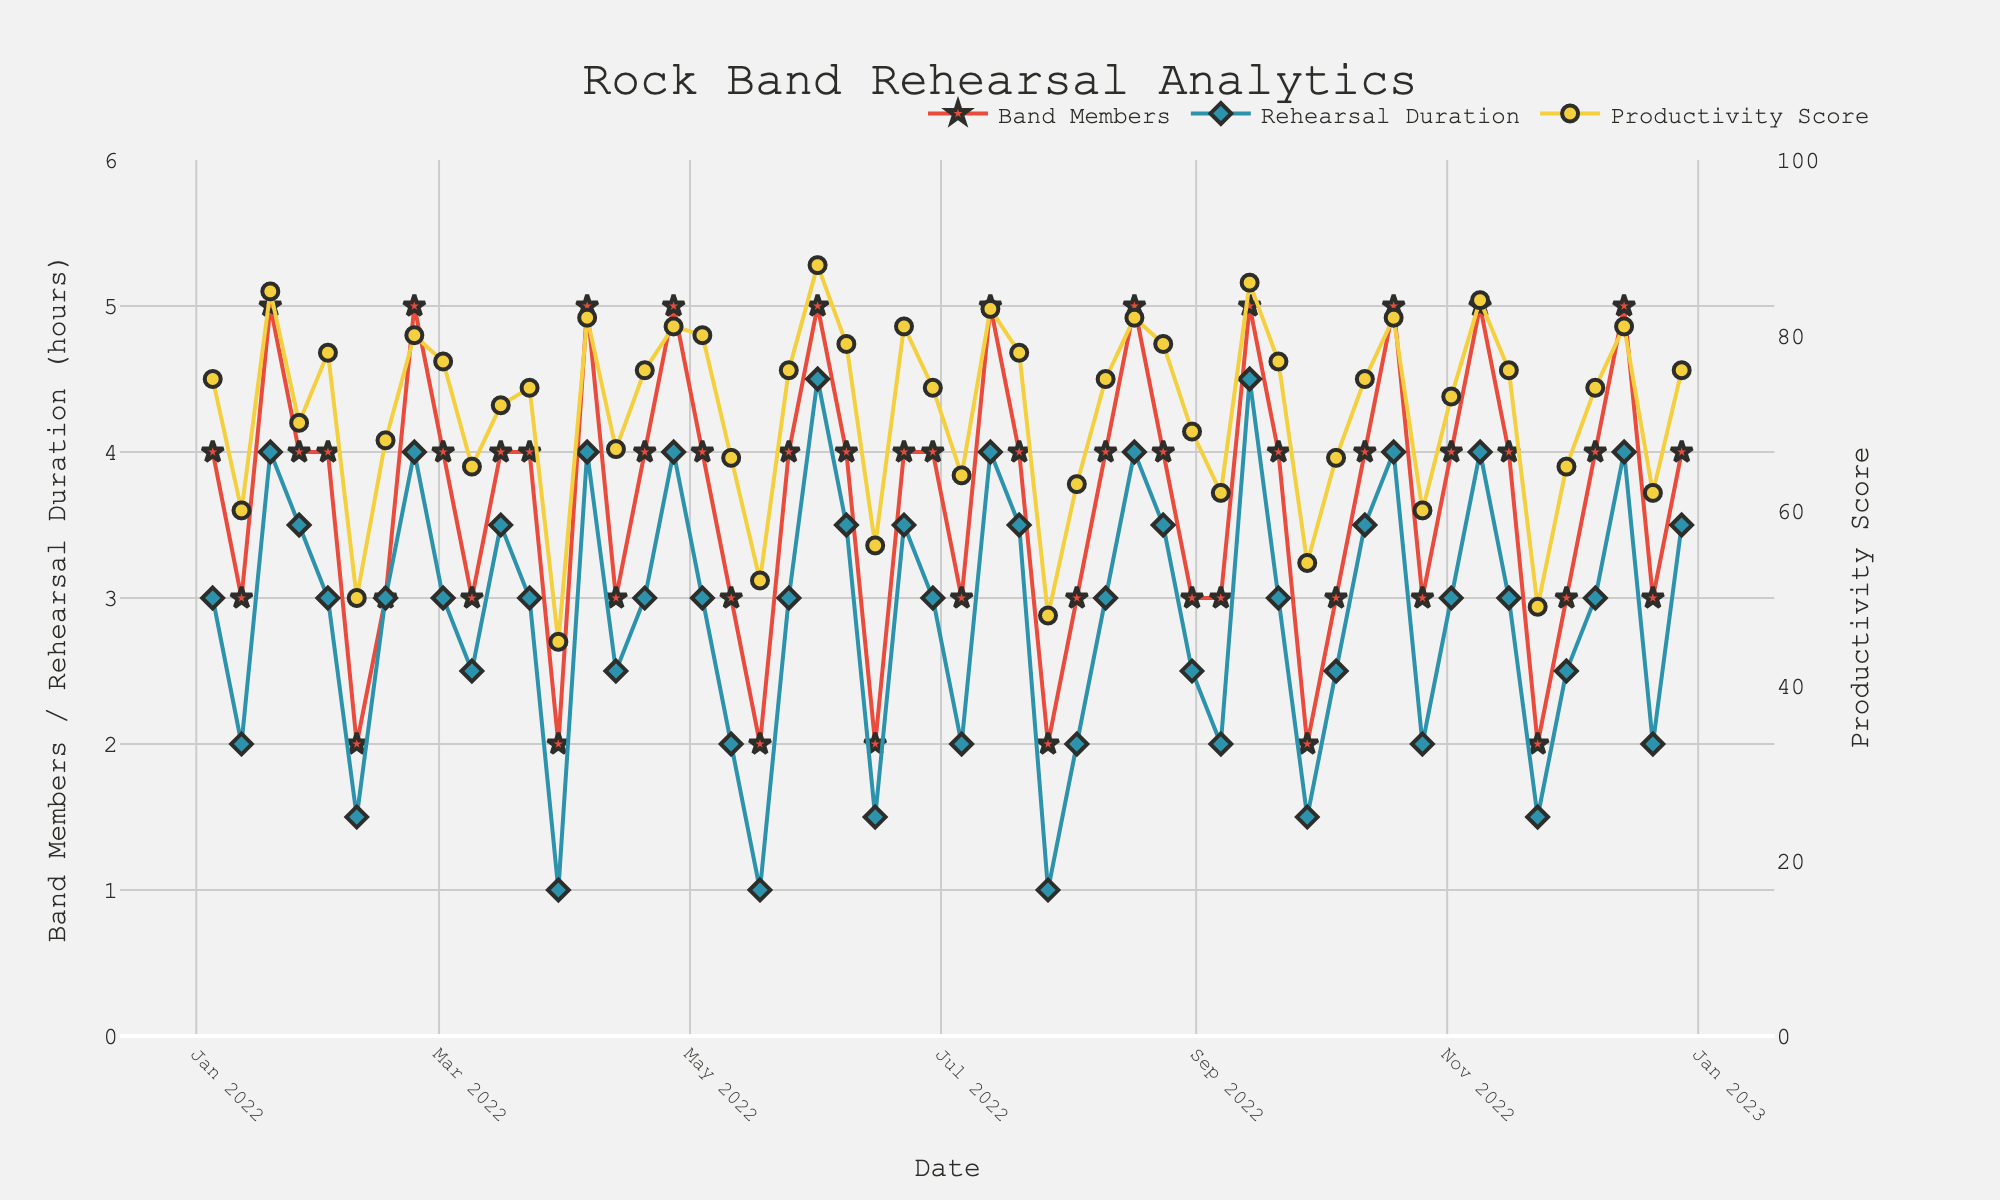How many band members were present at the rehearsal on 2022-04-06? Locate the date 2022-04-06 on the x-axis and follow vertically up to the "Band Members" line, which indicates the number of band members present. The value at this point is 5.
Answer: 5 What is the highest productivity score recorded in the past year? Find the peak point on the "Productivity Score" line and check its y-axis value. The highest productivity score is 88.
Answer: 88 On which date was the rehearsal duration the shortest, and what was its duration? Determine the lowest point on the "Rehearsal Duration" line and find the corresponding date on the x-axis. The shortest rehearsal duration (1 hour) occurred on both 2022-03-30 and 2022-07-27.
Answer: 2022-03-30, 2022-07-27, 1 hour What is the average productivity score for rehearsals in January 2022? Locate the productivity scores for all dates in January 2022: 75, 60, 85, 70. Sum them up (75 + 60 + 85 + 70 = 290) and divide by the number of dates (4). The average productivity score is 290 / 4 = 72.5.
Answer: 72.5 Compare the productivity scores for rehearsals with 5 band members present versus those with 2 band members present. Which group has higher productivity on average? Collect all productivity scores where band members present are 5: 85, 80, 82, 81, 88, 83, 82, 86, 82, 84, 81. Calculate the average (sum = 924, count = 11), so 924 / 11 ≈ 84. Comparing with scores where band members present are 2: 50, 45, 52, 56, 48, 54, 49 (sum = 354, count = 7), so 354 / 7 = 50.57. The group with 5 band members present has a higher average productivity score.
Answer: 5 band members Does the productivity score generally increase with the number of band members present? Review the plot where the band members' presence is high, then observe the productivity score trends. Higher attendance (4 or 5 members) usually corresponds to higher productivity scores, suggesting a positive relationship.
Answer: Yes 